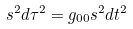Convert formula to latex. <formula><loc_0><loc_0><loc_500><loc_500>s ^ { 2 } d \tau ^ { 2 } = g _ { 0 0 } s ^ { 2 } d t ^ { 2 }</formula> 